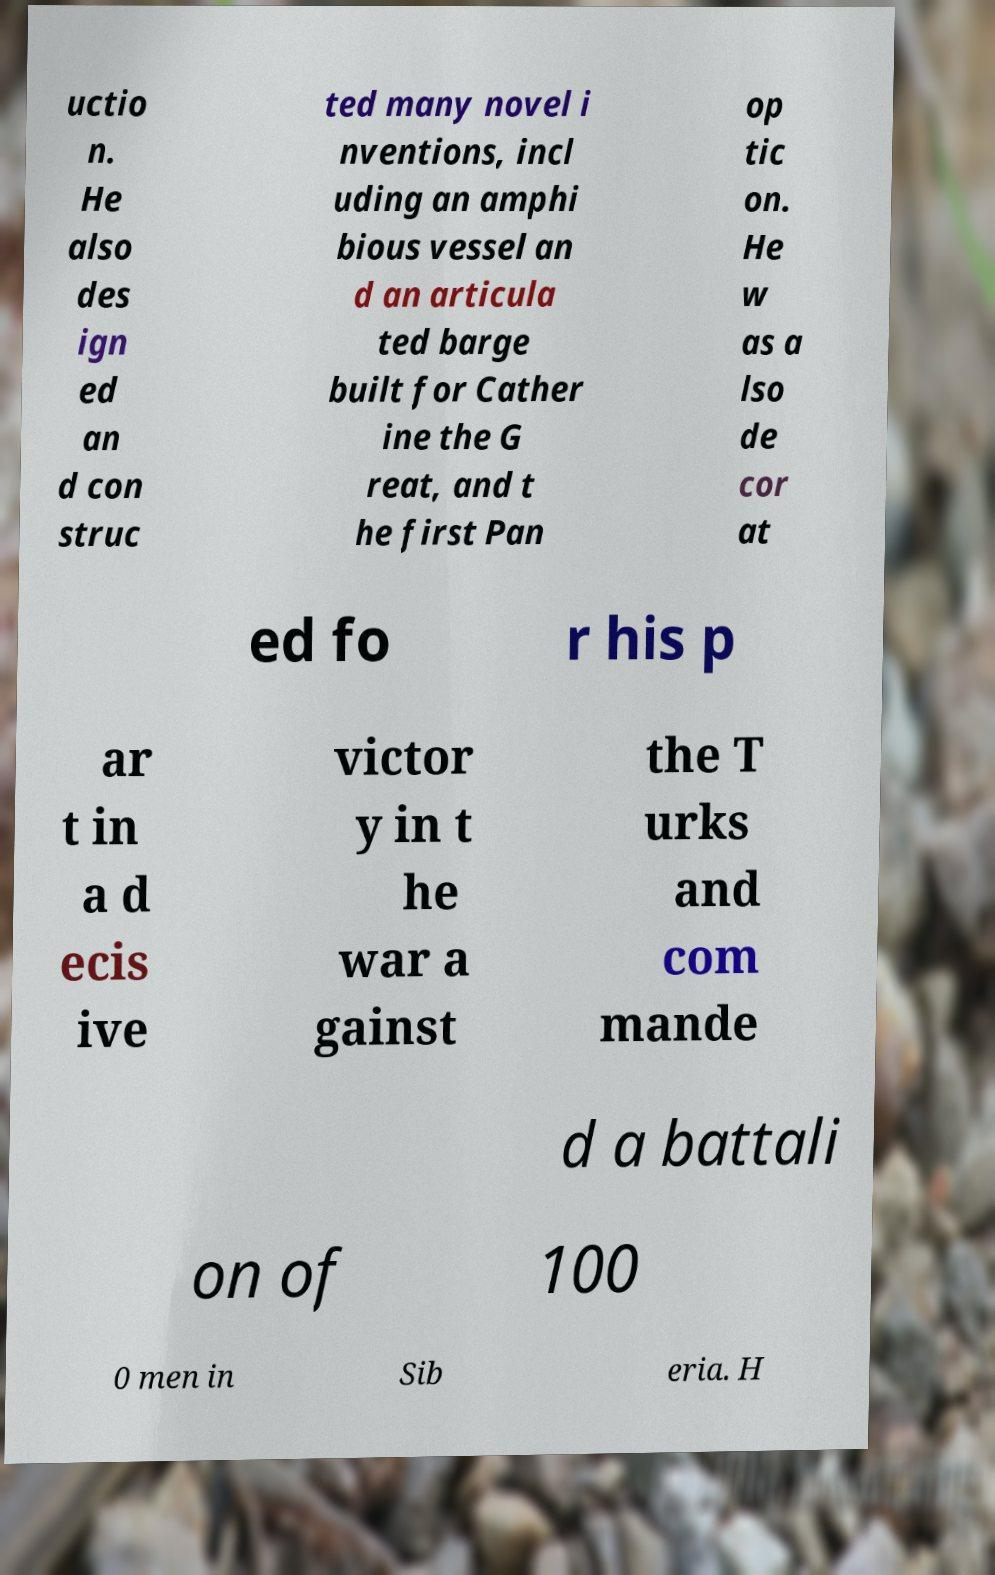For documentation purposes, I need the text within this image transcribed. Could you provide that? uctio n. He also des ign ed an d con struc ted many novel i nventions, incl uding an amphi bious vessel an d an articula ted barge built for Cather ine the G reat, and t he first Pan op tic on. He w as a lso de cor at ed fo r his p ar t in a d ecis ive victor y in t he war a gainst the T urks and com mande d a battali on of 100 0 men in Sib eria. H 